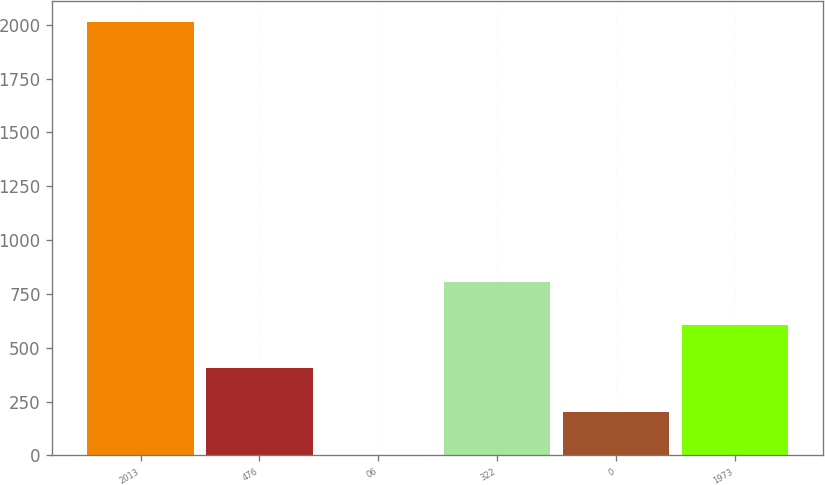Convert chart. <chart><loc_0><loc_0><loc_500><loc_500><bar_chart><fcel>2013<fcel>476<fcel>06<fcel>322<fcel>0<fcel>1973<nl><fcel>2011<fcel>403.8<fcel>2<fcel>805.6<fcel>202.9<fcel>604.7<nl></chart> 